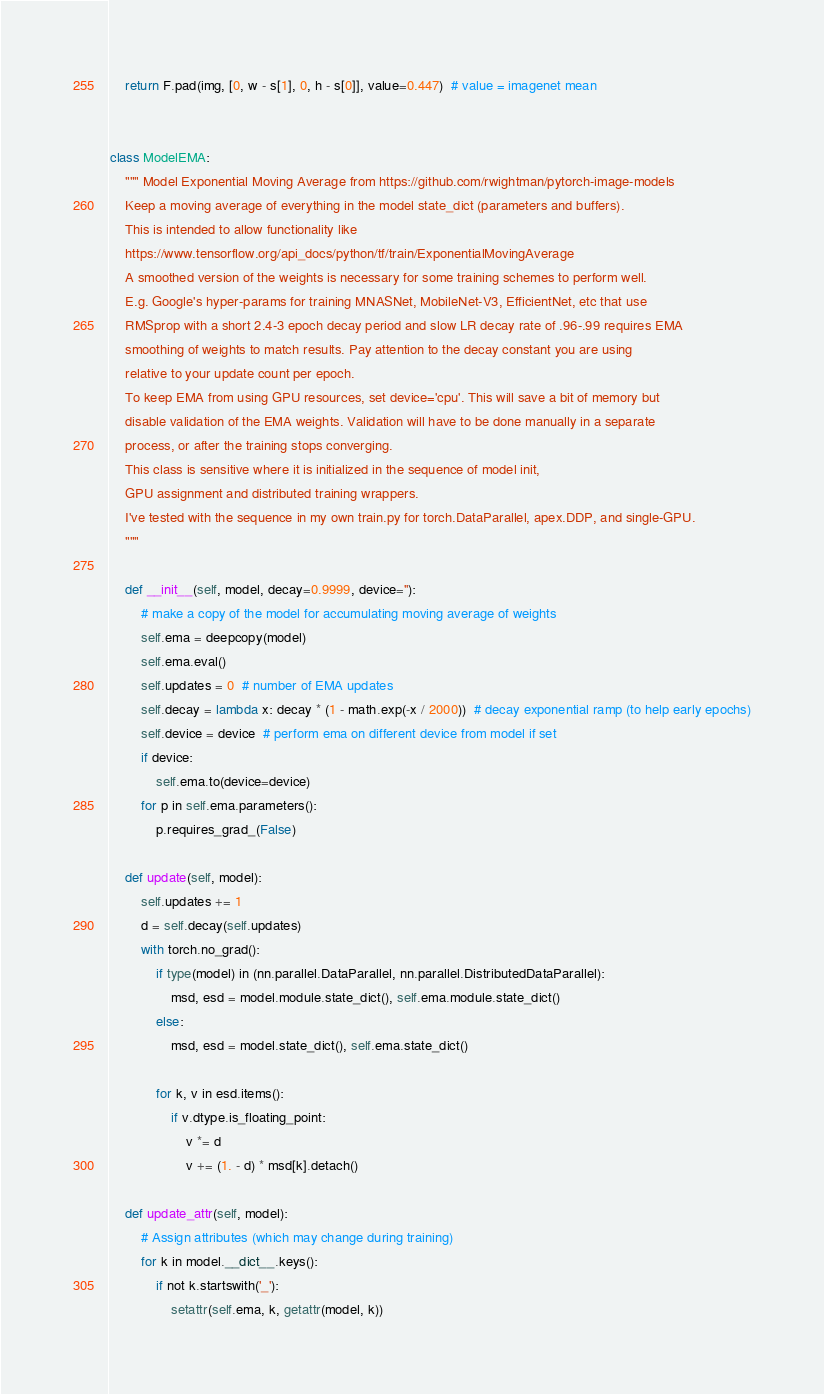<code> <loc_0><loc_0><loc_500><loc_500><_Python_>    return F.pad(img, [0, w - s[1], 0, h - s[0]], value=0.447)  # value = imagenet mean


class ModelEMA:
    """ Model Exponential Moving Average from https://github.com/rwightman/pytorch-image-models
    Keep a moving average of everything in the model state_dict (parameters and buffers).
    This is intended to allow functionality like
    https://www.tensorflow.org/api_docs/python/tf/train/ExponentialMovingAverage
    A smoothed version of the weights is necessary for some training schemes to perform well.
    E.g. Google's hyper-params for training MNASNet, MobileNet-V3, EfficientNet, etc that use
    RMSprop with a short 2.4-3 epoch decay period and slow LR decay rate of .96-.99 requires EMA
    smoothing of weights to match results. Pay attention to the decay constant you are using
    relative to your update count per epoch.
    To keep EMA from using GPU resources, set device='cpu'. This will save a bit of memory but
    disable validation of the EMA weights. Validation will have to be done manually in a separate
    process, or after the training stops converging.
    This class is sensitive where it is initialized in the sequence of model init,
    GPU assignment and distributed training wrappers.
    I've tested with the sequence in my own train.py for torch.DataParallel, apex.DDP, and single-GPU.
    """

    def __init__(self, model, decay=0.9999, device=''):
        # make a copy of the model for accumulating moving average of weights
        self.ema = deepcopy(model)
        self.ema.eval()
        self.updates = 0  # number of EMA updates
        self.decay = lambda x: decay * (1 - math.exp(-x / 2000))  # decay exponential ramp (to help early epochs)
        self.device = device  # perform ema on different device from model if set
        if device:
            self.ema.to(device=device)
        for p in self.ema.parameters():
            p.requires_grad_(False)

    def update(self, model):
        self.updates += 1
        d = self.decay(self.updates)
        with torch.no_grad():
            if type(model) in (nn.parallel.DataParallel, nn.parallel.DistributedDataParallel):
                msd, esd = model.module.state_dict(), self.ema.module.state_dict()
            else:
                msd, esd = model.state_dict(), self.ema.state_dict()

            for k, v in esd.items():
                if v.dtype.is_floating_point:
                    v *= d
                    v += (1. - d) * msd[k].detach()

    def update_attr(self, model):
        # Assign attributes (which may change during training)
        for k in model.__dict__.keys():
            if not k.startswith('_'):
                setattr(self.ema, k, getattr(model, k))
</code> 